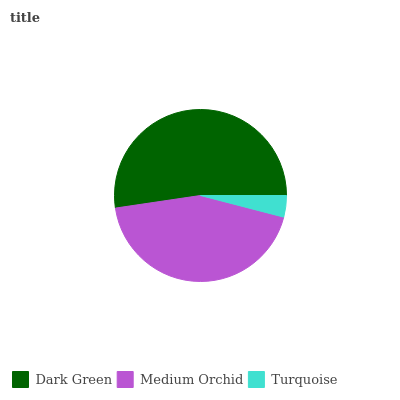Is Turquoise the minimum?
Answer yes or no. Yes. Is Dark Green the maximum?
Answer yes or no. Yes. Is Medium Orchid the minimum?
Answer yes or no. No. Is Medium Orchid the maximum?
Answer yes or no. No. Is Dark Green greater than Medium Orchid?
Answer yes or no. Yes. Is Medium Orchid less than Dark Green?
Answer yes or no. Yes. Is Medium Orchid greater than Dark Green?
Answer yes or no. No. Is Dark Green less than Medium Orchid?
Answer yes or no. No. Is Medium Orchid the high median?
Answer yes or no. Yes. Is Medium Orchid the low median?
Answer yes or no. Yes. Is Turquoise the high median?
Answer yes or no. No. Is Turquoise the low median?
Answer yes or no. No. 